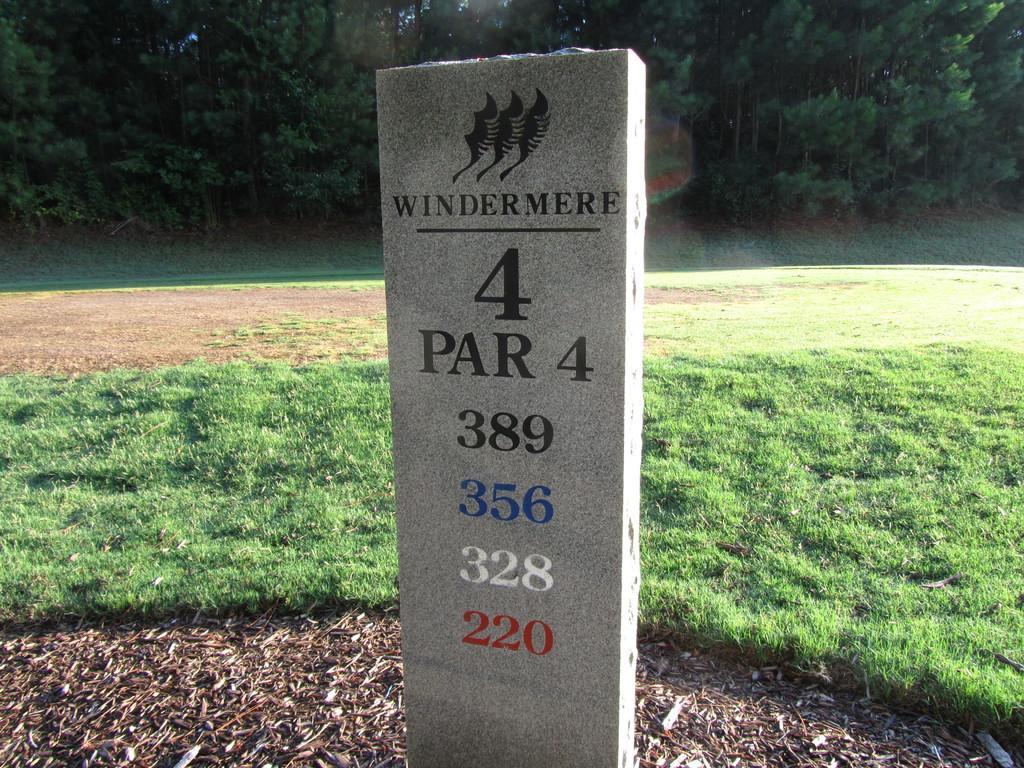Could you give a brief overview of what you see in this image? On a mile stone,there are some numbers are written and behind the stone there is a grass and in the background there are many trees. 